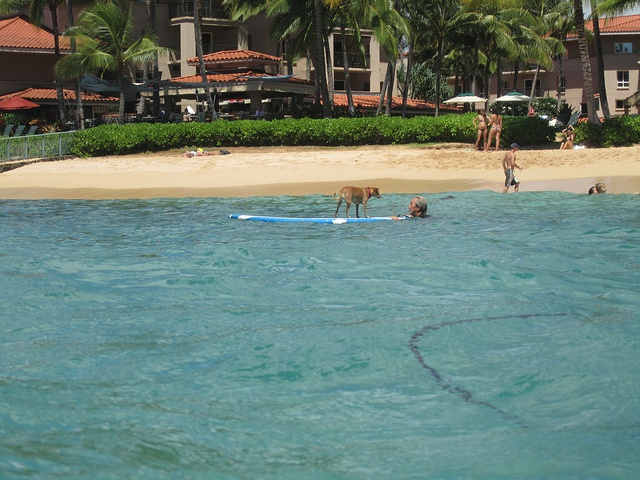Describe the objects in this image and their specific colors. I can see surfboard in olive, gray, lightblue, and white tones, dog in olive, gray, tan, and maroon tones, people in olive, darkgray, gray, and black tones, people in olive, gray, tan, and darkgray tones, and people in olive, brown, black, maroon, and tan tones in this image. 